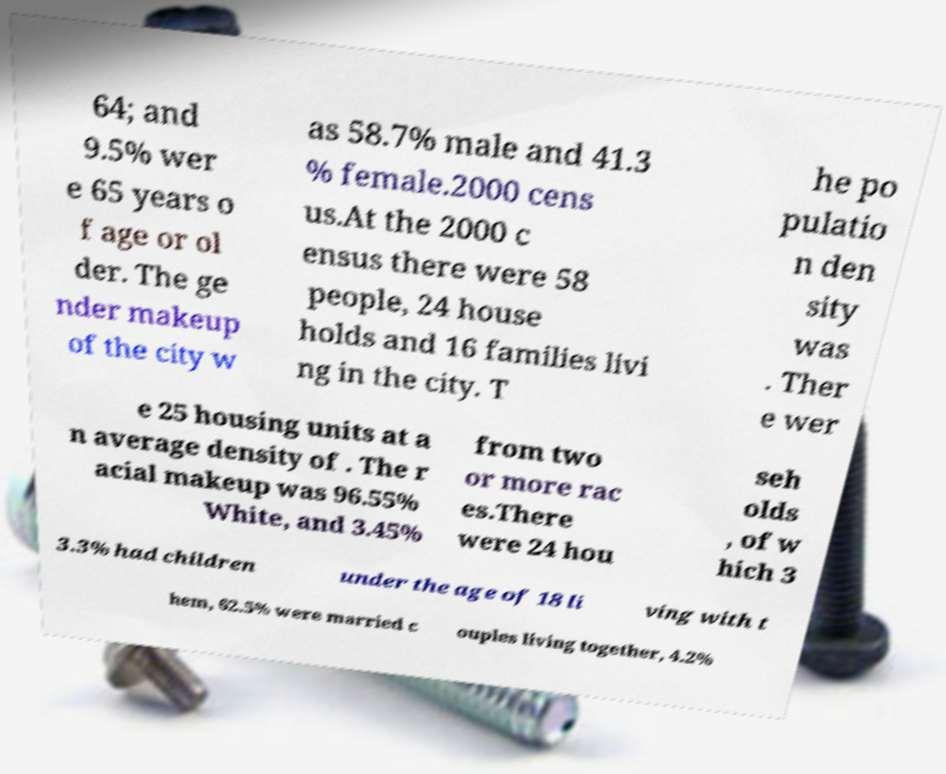Can you read and provide the text displayed in the image?This photo seems to have some interesting text. Can you extract and type it out for me? 64; and 9.5% wer e 65 years o f age or ol der. The ge nder makeup of the city w as 58.7% male and 41.3 % female.2000 cens us.At the 2000 c ensus there were 58 people, 24 house holds and 16 families livi ng in the city. T he po pulatio n den sity was . Ther e wer e 25 housing units at a n average density of . The r acial makeup was 96.55% White, and 3.45% from two or more rac es.There were 24 hou seh olds , of w hich 3 3.3% had children under the age of 18 li ving with t hem, 62.5% were married c ouples living together, 4.2% 